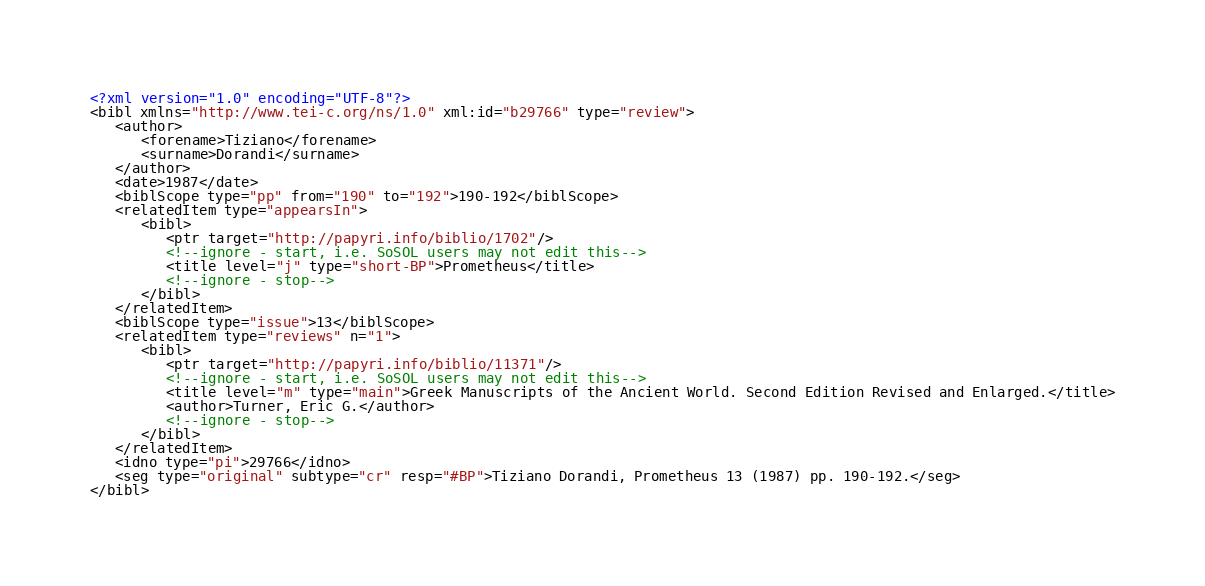<code> <loc_0><loc_0><loc_500><loc_500><_XML_><?xml version="1.0" encoding="UTF-8"?>
<bibl xmlns="http://www.tei-c.org/ns/1.0" xml:id="b29766" type="review">
   <author>
      <forename>Tiziano</forename>
      <surname>Dorandi</surname>
   </author>
   <date>1987</date>
   <biblScope type="pp" from="190" to="192">190-192</biblScope>
   <relatedItem type="appearsIn">
      <bibl>
         <ptr target="http://papyri.info/biblio/1702"/>
         <!--ignore - start, i.e. SoSOL users may not edit this-->
         <title level="j" type="short-BP">Prometheus</title>
         <!--ignore - stop-->
      </bibl>
   </relatedItem>
   <biblScope type="issue">13</biblScope>
   <relatedItem type="reviews" n="1">
      <bibl>
         <ptr target="http://papyri.info/biblio/11371"/>
         <!--ignore - start, i.e. SoSOL users may not edit this-->
         <title level="m" type="main">Greek Manuscripts of the Ancient World. Second Edition Revised and Enlarged.</title>
         <author>Turner, Eric G.</author>
         <!--ignore - stop-->
      </bibl>
   </relatedItem>
   <idno type="pi">29766</idno>
   <seg type="original" subtype="cr" resp="#BP">Tiziano Dorandi, Prometheus 13 (1987) pp. 190-192.</seg>
</bibl>
</code> 